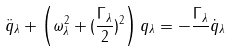<formula> <loc_0><loc_0><loc_500><loc_500>\ddot { q } _ { \lambda } + \left ( \omega _ { \lambda } ^ { 2 } + ( \frac { \Gamma _ { \lambda } } { 2 } ) ^ { 2 } \right ) q _ { \lambda } = - \frac { \Gamma _ { \lambda } } { } \dot { q } _ { \lambda }</formula> 